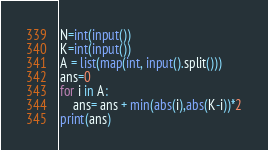<code> <loc_0><loc_0><loc_500><loc_500><_Python_>N=int(input())
K=int(input())
A = list(map(int, input().split()))
ans=0
for i in A:
    ans= ans + min(abs(i),abs(K-i))*2
print(ans)</code> 